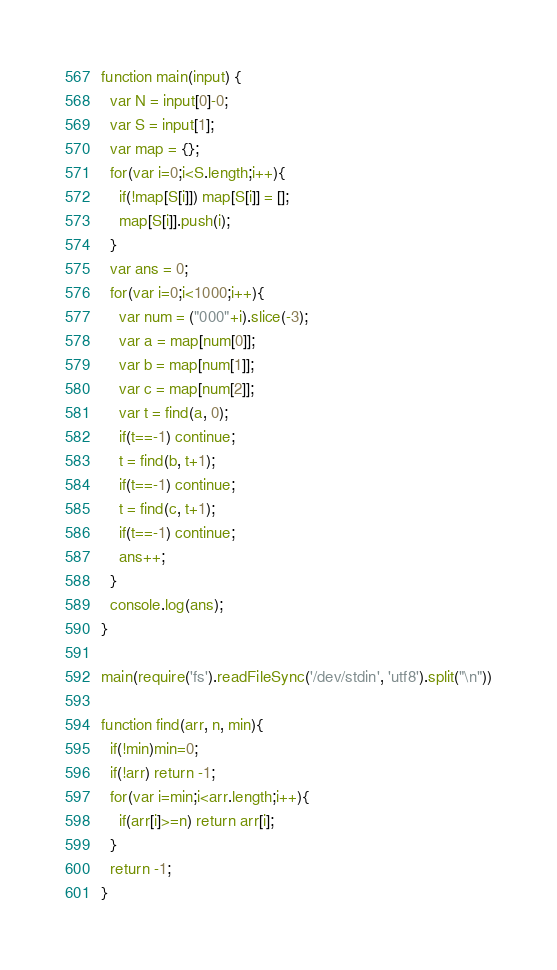Convert code to text. <code><loc_0><loc_0><loc_500><loc_500><_JavaScript_>function main(input) {
  var N = input[0]-0;
  var S = input[1];
  var map = {};
  for(var i=0;i<S.length;i++){
    if(!map[S[i]]) map[S[i]] = [];
    map[S[i]].push(i);
  }
  var ans = 0;
  for(var i=0;i<1000;i++){
    var num = ("000"+i).slice(-3);
    var a = map[num[0]];
    var b = map[num[1]];
    var c = map[num[2]];
    var t = find(a, 0);
    if(t==-1) continue;
    t = find(b, t+1);
    if(t==-1) continue;
    t = find(c, t+1);
    if(t==-1) continue;
    ans++;
  }
  console.log(ans);
}

main(require('fs').readFileSync('/dev/stdin', 'utf8').split("\n"))

function find(arr, n, min){
  if(!min)min=0;
  if(!arr) return -1;
  for(var i=min;i<arr.length;i++){
    if(arr[i]>=n) return arr[i];
  }
  return -1;
}
</code> 